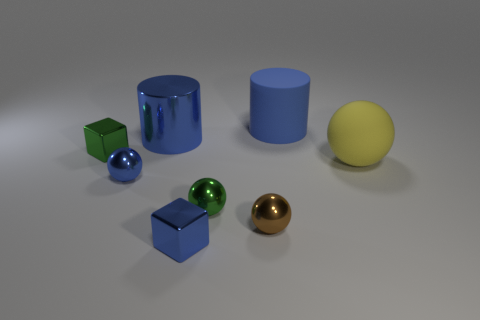Is the number of big blue metal cylinders that are in front of the metallic cylinder less than the number of tiny green metal spheres that are behind the yellow rubber ball?
Provide a succinct answer. No. How many other things are there of the same size as the blue metal block?
Provide a succinct answer. 4. There is a large blue metal thing behind the big object in front of the small object that is behind the big sphere; what is its shape?
Offer a very short reply. Cylinder. How many blue objects are tiny spheres or small objects?
Your answer should be compact. 2. What number of blue cylinders are behind the big blue thing that is in front of the big matte cylinder?
Your answer should be compact. 1. Is there anything else that is the same color as the large shiny cylinder?
Offer a terse response. Yes. The tiny brown thing that is made of the same material as the tiny blue block is what shape?
Your response must be concise. Sphere. Does the large metallic thing have the same color as the big matte cylinder?
Give a very brief answer. Yes. Does the large blue cylinder that is in front of the blue rubber cylinder have the same material as the tiny green thing behind the big matte sphere?
Keep it short and to the point. Yes. How many objects are small cubes or blue shiny things behind the large yellow object?
Your response must be concise. 3. 